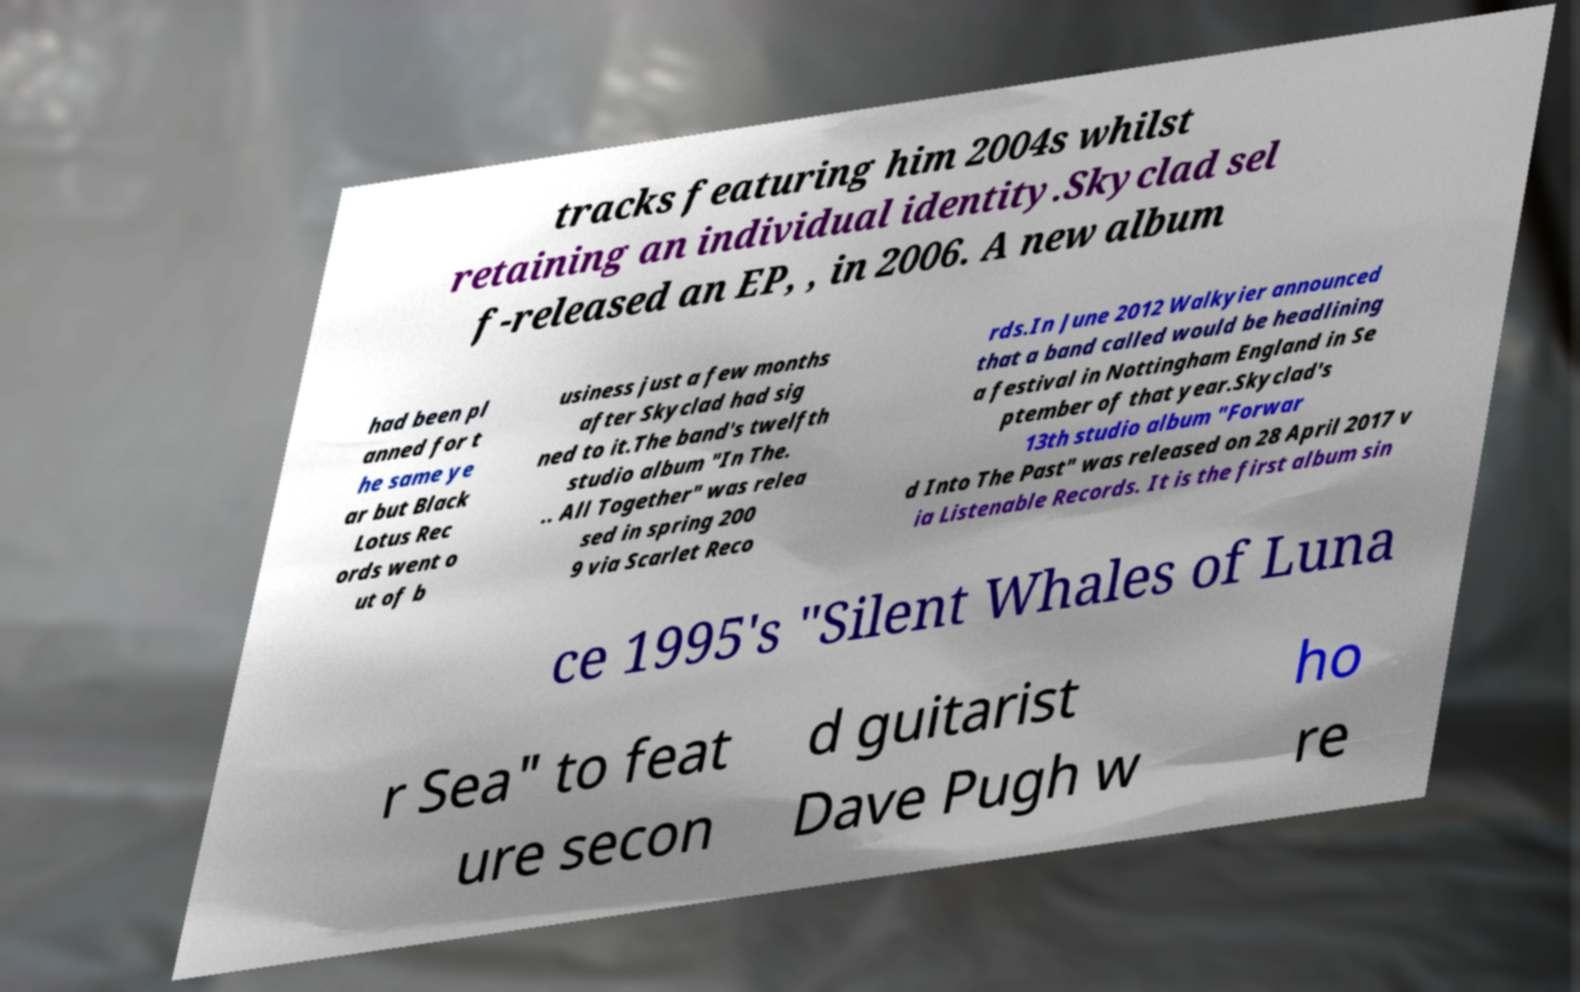Could you extract and type out the text from this image? tracks featuring him 2004s whilst retaining an individual identity.Skyclad sel f-released an EP, , in 2006. A new album had been pl anned for t he same ye ar but Black Lotus Rec ords went o ut of b usiness just a few months after Skyclad had sig ned to it.The band's twelfth studio album "In The. .. All Together" was relea sed in spring 200 9 via Scarlet Reco rds.In June 2012 Walkyier announced that a band called would be headlining a festival in Nottingham England in Se ptember of that year.Skyclad's 13th studio album "Forwar d Into The Past" was released on 28 April 2017 v ia Listenable Records. It is the first album sin ce 1995's "Silent Whales of Luna r Sea" to feat ure secon d guitarist Dave Pugh w ho re 